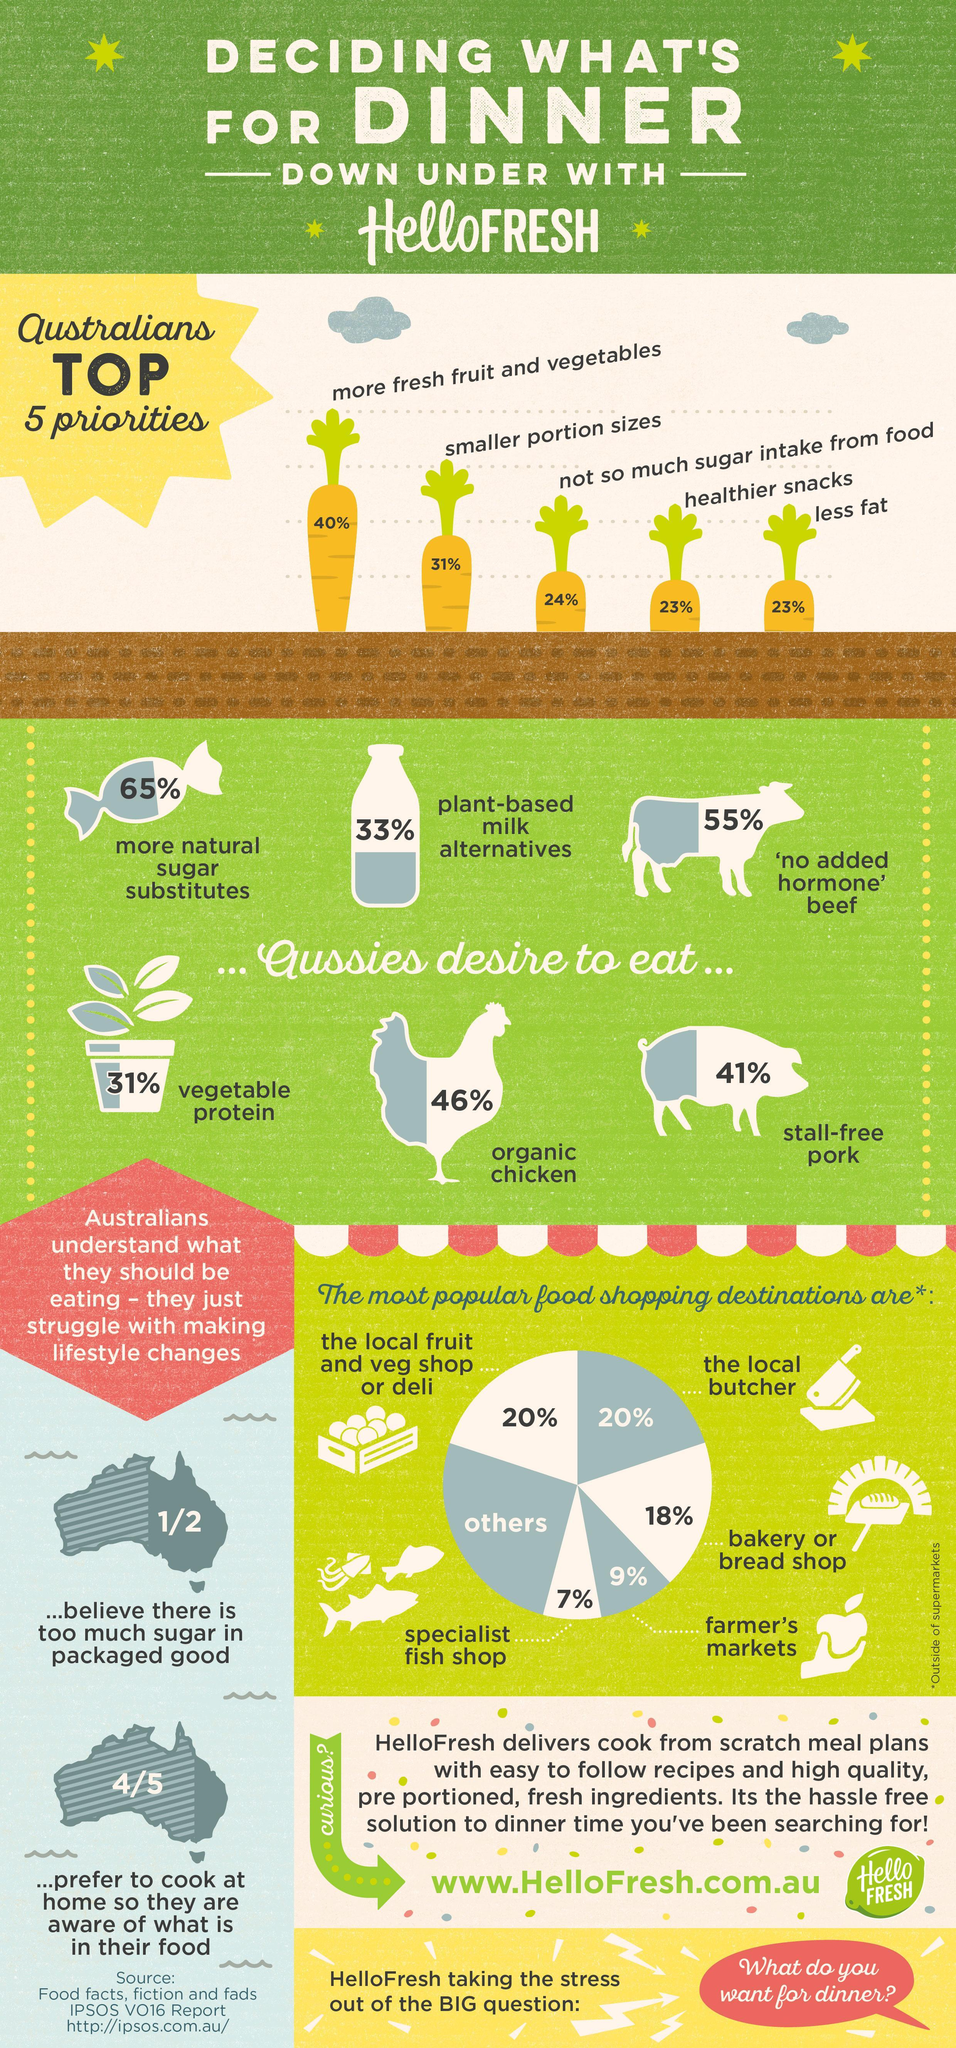What percentage of Australians visit the local butcher or vegetable shop?
Answer the question with a short phrase. 20% What percentage of Australians are trying to eat healthier snacks and less fat? 23% What percentage of Aussies would like to eat  chicken free from antibiotics, 46%, 31%, or 41% 46% Which animal products do the Australians love to consume? beef, chicken, pork 